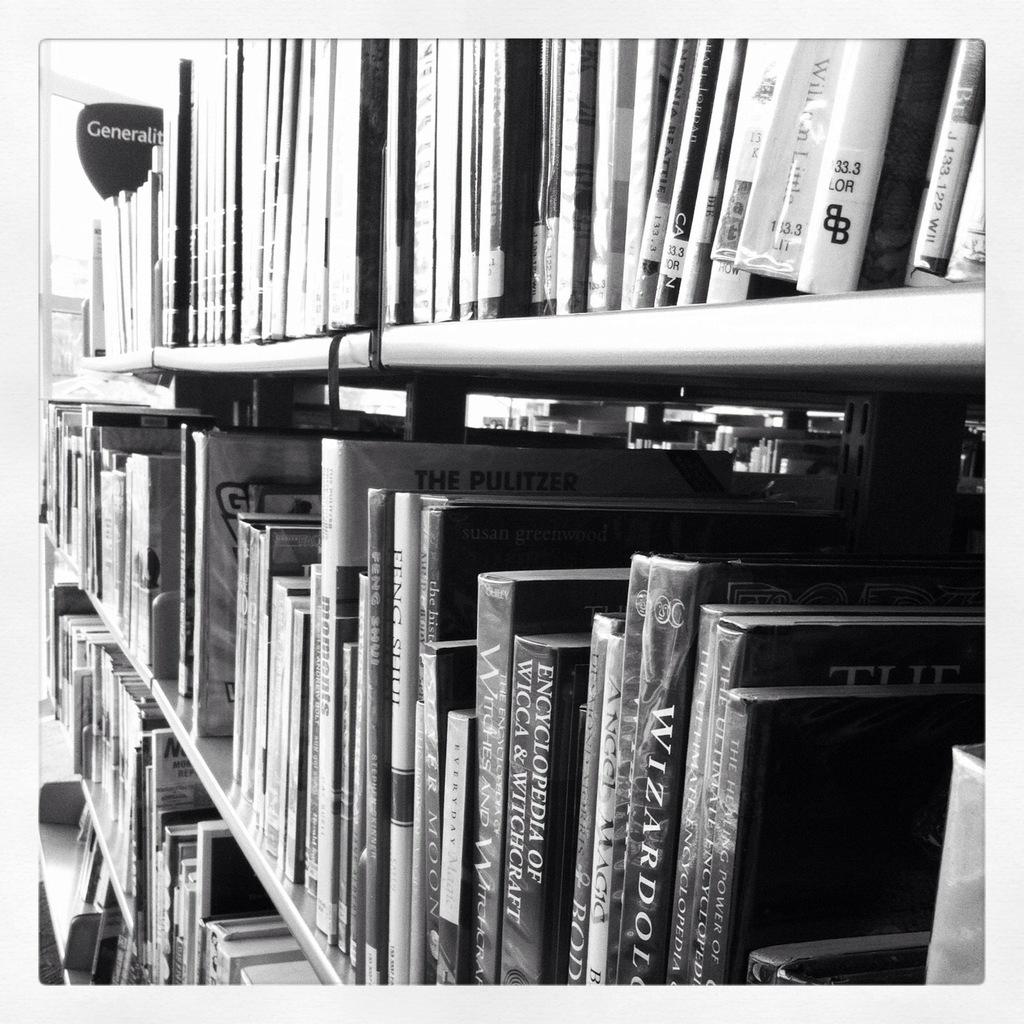What kind of encyclopedia can you see?
Offer a terse response. Wicca & witchcraft. What numbers can you see on the top right?
Ensure brevity in your answer.  33.3. 